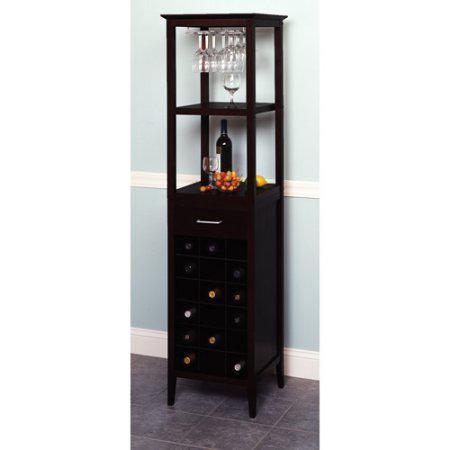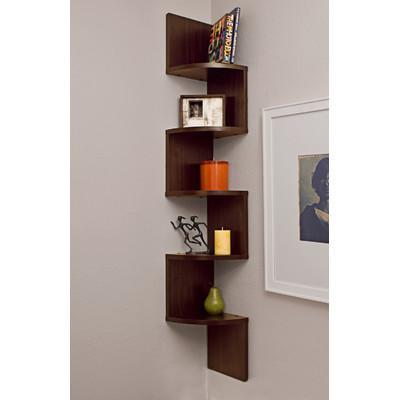The first image is the image on the left, the second image is the image on the right. For the images displayed, is the sentence "Both shelf units can stand on their own." factually correct? Answer yes or no. No. The first image is the image on the left, the second image is the image on the right. For the images shown, is this caption "The left image shows a dark bookcase with short legs, a top part that is open, and a bottom part at least partly closed." true? Answer yes or no. Yes. 